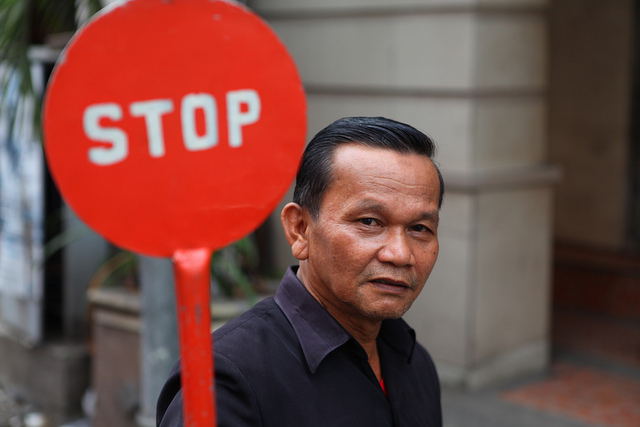<image>Is the man in uniform? The man is not in the uniform. Is the man in uniform? The man in the image is not wearing uniform. 